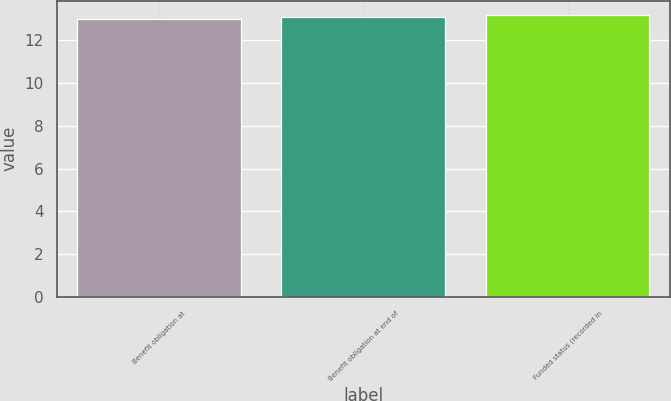Convert chart to OTSL. <chart><loc_0><loc_0><loc_500><loc_500><bar_chart><fcel>Benefit obligation at<fcel>Benefit obligation at end of<fcel>Funded status (recorded in<nl><fcel>13<fcel>13.1<fcel>13.2<nl></chart> 